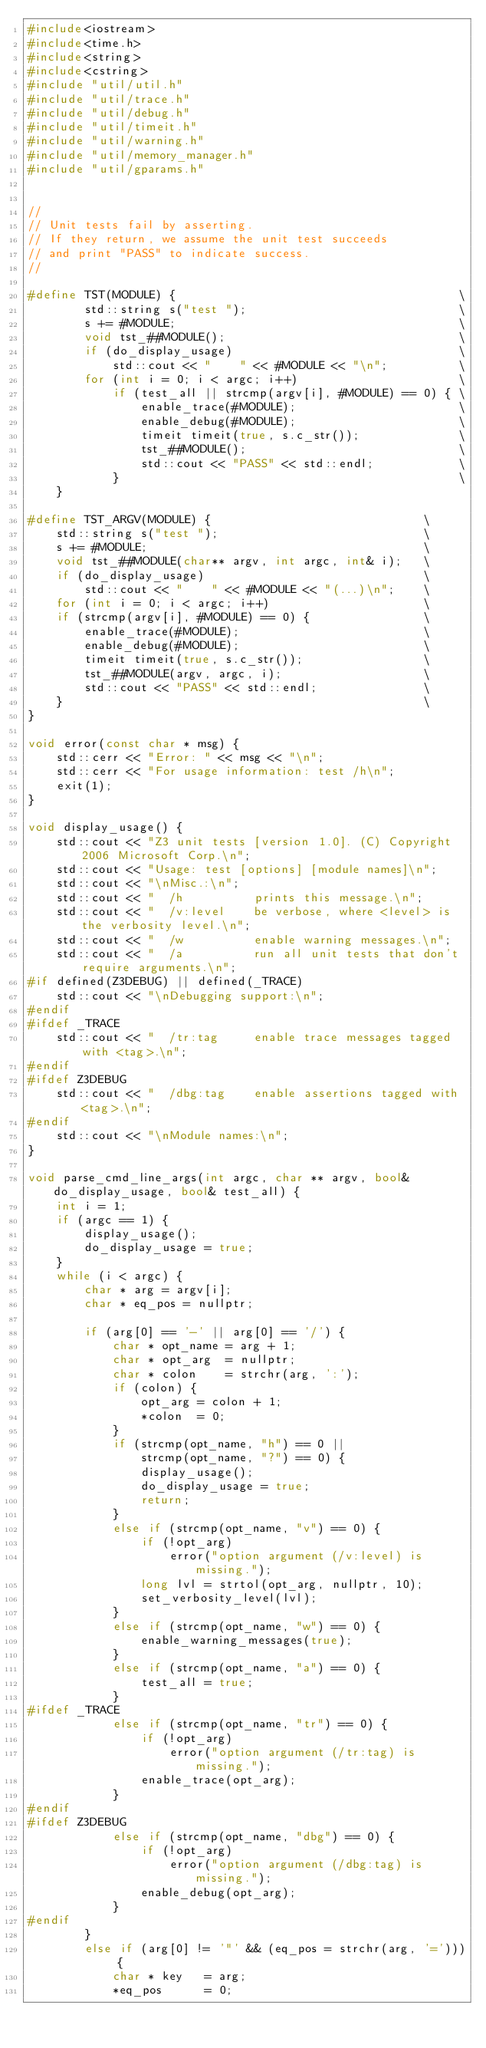Convert code to text. <code><loc_0><loc_0><loc_500><loc_500><_C++_>#include<iostream>
#include<time.h>
#include<string>
#include<cstring>
#include "util/util.h"
#include "util/trace.h"
#include "util/debug.h"
#include "util/timeit.h"
#include "util/warning.h"
#include "util/memory_manager.h"
#include "util/gparams.h"


//
// Unit tests fail by asserting.
// If they return, we assume the unit test succeeds
// and print "PASS" to indicate success.
//

#define TST(MODULE) {                                        \
        std::string s("test ");                              \
        s += #MODULE;                                        \
        void tst_##MODULE();                                 \
        if (do_display_usage)                                \
            std::cout << "    " << #MODULE << "\n";          \
        for (int i = 0; i < argc; i++)                       \
            if (test_all || strcmp(argv[i], #MODULE) == 0) { \
                enable_trace(#MODULE);                       \
                enable_debug(#MODULE);                       \
                timeit timeit(true, s.c_str());              \
                tst_##MODULE();                              \
                std::cout << "PASS" << std::endl;            \
            }                                                \
    }

#define TST_ARGV(MODULE) {                              \
    std::string s("test ");                             \
    s += #MODULE;                                       \
    void tst_##MODULE(char** argv, int argc, int& i);   \
    if (do_display_usage)                               \
        std::cout << "    " << #MODULE << "(...)\n";    \
    for (int i = 0; i < argc; i++)                      \
    if (strcmp(argv[i], #MODULE) == 0) {                \
        enable_trace(#MODULE);                          \
        enable_debug(#MODULE);                          \
        timeit timeit(true, s.c_str());                 \
        tst_##MODULE(argv, argc, i);                    \
        std::cout << "PASS" << std::endl;               \
    }                                                   \
}

void error(const char * msg) {
    std::cerr << "Error: " << msg << "\n";
    std::cerr << "For usage information: test /h\n";
    exit(1);
}

void display_usage() {
    std::cout << "Z3 unit tests [version 1.0]. (C) Copyright 2006 Microsoft Corp.\n";
    std::cout << "Usage: test [options] [module names]\n";
    std::cout << "\nMisc.:\n";
    std::cout << "  /h          prints this message.\n";
    std::cout << "  /v:level    be verbose, where <level> is the verbosity level.\n";
    std::cout << "  /w          enable warning messages.\n";
    std::cout << "  /a          run all unit tests that don't require arguments.\n";
#if defined(Z3DEBUG) || defined(_TRACE)
    std::cout << "\nDebugging support:\n";
#endif
#ifdef _TRACE
    std::cout << "  /tr:tag     enable trace messages tagged with <tag>.\n";
#endif
#ifdef Z3DEBUG
    std::cout << "  /dbg:tag    enable assertions tagged with <tag>.\n";
#endif
    std::cout << "\nModule names:\n";
}

void parse_cmd_line_args(int argc, char ** argv, bool& do_display_usage, bool& test_all) {
    int i = 1;
    if (argc == 1) {
        display_usage();
        do_display_usage = true;
    }
    while (i < argc) {
        char * arg = argv[i];
        char * eq_pos = nullptr;

        if (arg[0] == '-' || arg[0] == '/') {
            char * opt_name = arg + 1;
            char * opt_arg  = nullptr;
            char * colon    = strchr(arg, ':');
            if (colon) {
                opt_arg = colon + 1;
                *colon  = 0;
            }
            if (strcmp(opt_name, "h") == 0 ||
                strcmp(opt_name, "?") == 0) {
                display_usage();
                do_display_usage = true;
                return;
            }
            else if (strcmp(opt_name, "v") == 0) {
                if (!opt_arg)
                    error("option argument (/v:level) is missing.");
                long lvl = strtol(opt_arg, nullptr, 10);
                set_verbosity_level(lvl);
            }
            else if (strcmp(opt_name, "w") == 0) {
                enable_warning_messages(true);
            }
            else if (strcmp(opt_name, "a") == 0) {
                test_all = true;
            }
#ifdef _TRACE
            else if (strcmp(opt_name, "tr") == 0) {
                if (!opt_arg)
                    error("option argument (/tr:tag) is missing.");
                enable_trace(opt_arg);
            }
#endif
#ifdef Z3DEBUG
            else if (strcmp(opt_name, "dbg") == 0) {
                if (!opt_arg)
                    error("option argument (/dbg:tag) is missing.");
                enable_debug(opt_arg);
            }
#endif
        }
        else if (arg[0] != '"' && (eq_pos = strchr(arg, '='))) {
            char * key   = arg;
            *eq_pos      = 0;</code> 